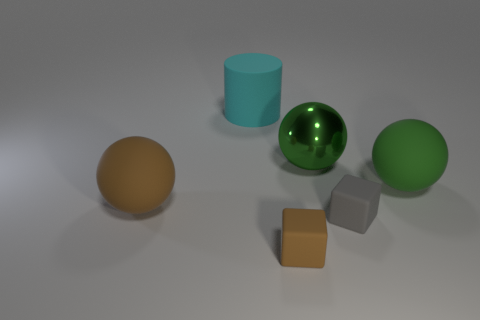The metallic object is what size?
Offer a terse response. Large. What number of cyan objects are small objects or shiny spheres?
Provide a succinct answer. 0. How many other matte things are the same shape as the tiny brown matte object?
Give a very brief answer. 1. How many green metal spheres are the same size as the green rubber thing?
Give a very brief answer. 1. There is a big brown object that is the same shape as the large green matte thing; what material is it?
Offer a very short reply. Rubber. There is a small cube that is behind the brown block; what is its color?
Your answer should be very brief. Gray. Are there more gray blocks that are on the right side of the big cyan rubber cylinder than large matte spheres?
Offer a very short reply. No. The shiny thing has what color?
Keep it short and to the point. Green. What shape is the thing that is to the right of the small rubber block behind the small matte object that is to the left of the small gray block?
Keep it short and to the point. Sphere. What material is the thing that is behind the big brown rubber object and to the right of the big shiny thing?
Give a very brief answer. Rubber. 